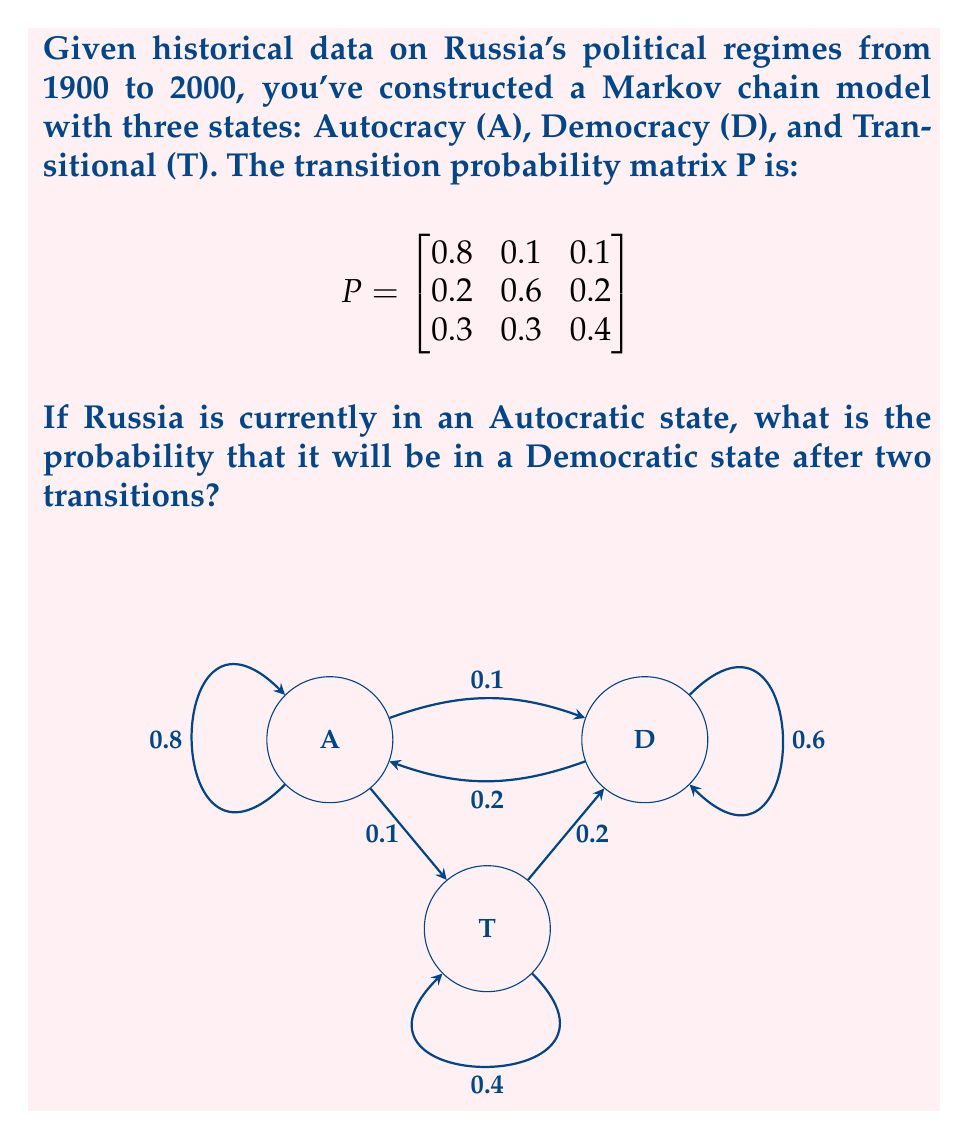Can you solve this math problem? To solve this problem, we need to use the properties of Markov chains and matrix multiplication. Let's proceed step-by-step:

1) The initial state vector is $v_0 = [1, 0, 0]$, representing that we start in the Autocratic state.

2) To find the probability distribution after two transitions, we need to multiply the initial state vector by the transition matrix twice:

   $v_2 = v_0 \cdot P^2$

3) Let's first calculate $P^2$:

   $$P^2 = \begin{bmatrix}
   0.8 & 0.1 & 0.1 \\
   0.2 & 0.6 & 0.2 \\
   0.3 & 0.3 & 0.4
   \end{bmatrix} \cdot 
   \begin{bmatrix}
   0.8 & 0.1 & 0.1 \\
   0.2 & 0.6 & 0.2 \\
   0.3 & 0.3 & 0.4
   \end{bmatrix}$$

4) Performing the matrix multiplication:

   $$P^2 = \begin{bmatrix}
   0.67 & 0.19 & 0.14 \\
   0.34 & 0.42 & 0.24 \\
   0.45 & 0.33 & 0.22
   \end{bmatrix}$$

5) Now, we multiply the initial state vector by $P^2$:

   $v_2 = [1, 0, 0] \cdot \begin{bmatrix}
   0.67 & 0.19 & 0.14 \\
   0.34 & 0.42 & 0.24 \\
   0.45 & 0.33 & 0.22
   \end{bmatrix}$

6) This gives us:

   $v_2 = [0.67, 0.19, 0.14]$

7) The probability of being in the Democratic state (the second element of $v_2$) is 0.19 or 19%.
Answer: 0.19 